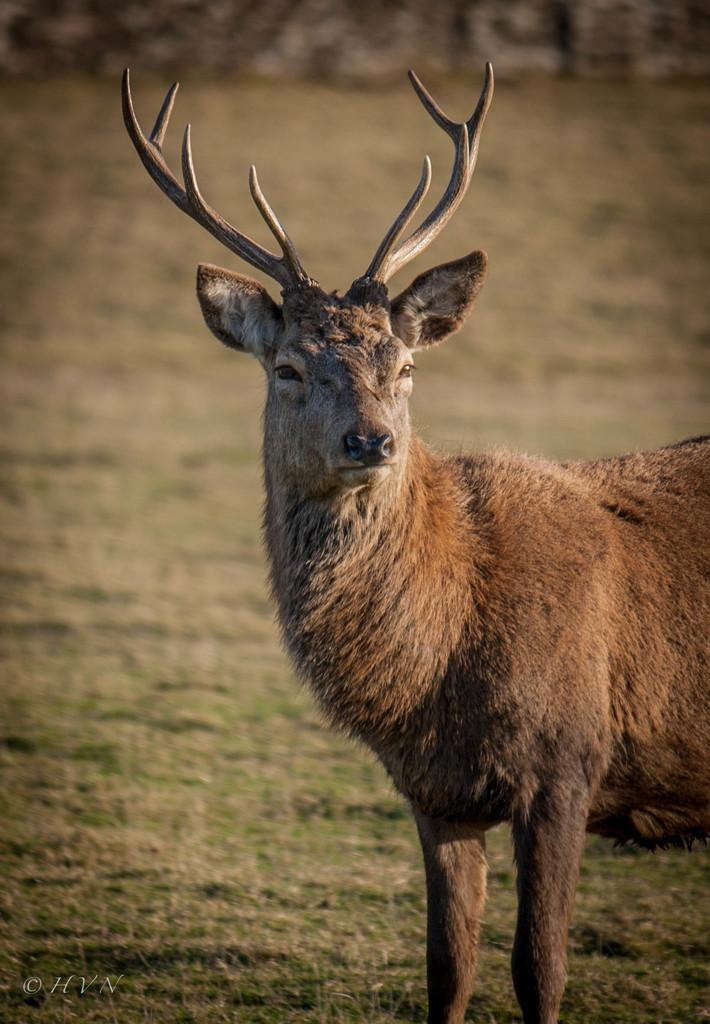What animal is in the foreground of the image? There is a deer in the foreground of the image. What is the deer standing on? The deer is on the grass. How many wrens are sitting on the deer's antlers in the image? There are no wrens present in the image, and the deer does not have any antlers. 